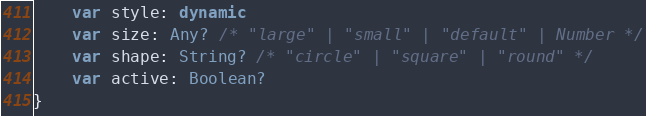<code> <loc_0><loc_0><loc_500><loc_500><_Kotlin_>    var style: dynamic
    var size: Any? /* "large" | "small" | "default" | Number */
    var shape: String? /* "circle" | "square" | "round" */
    var active: Boolean?
}
</code> 